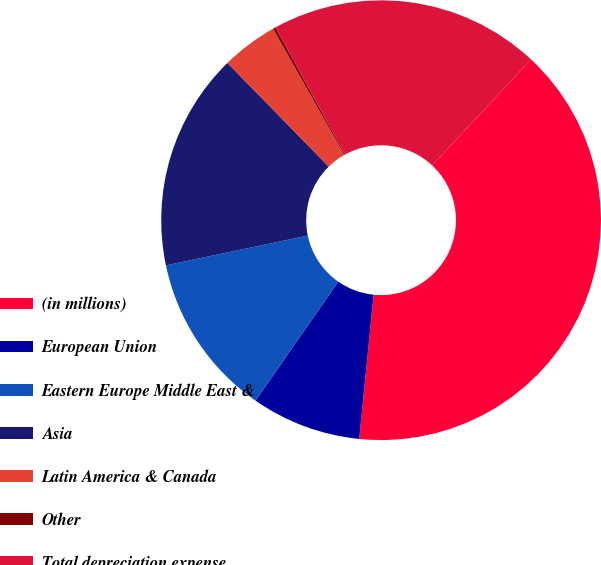Convert chart. <chart><loc_0><loc_0><loc_500><loc_500><pie_chart><fcel>(in millions)<fcel>European Union<fcel>Eastern Europe Middle East &<fcel>Asia<fcel>Latin America & Canada<fcel>Other<fcel>Total depreciation expense<nl><fcel>39.65%<fcel>8.09%<fcel>12.03%<fcel>15.98%<fcel>4.14%<fcel>0.2%<fcel>19.92%<nl></chart> 